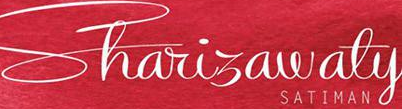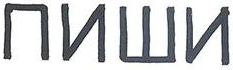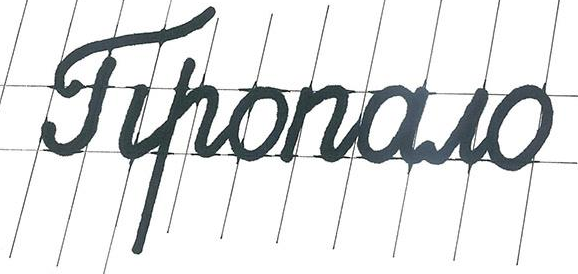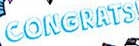What words are shown in these images in order, separated by a semicolon? Shariɜawaty; ##W#; Tiponowo; CONGRATS 